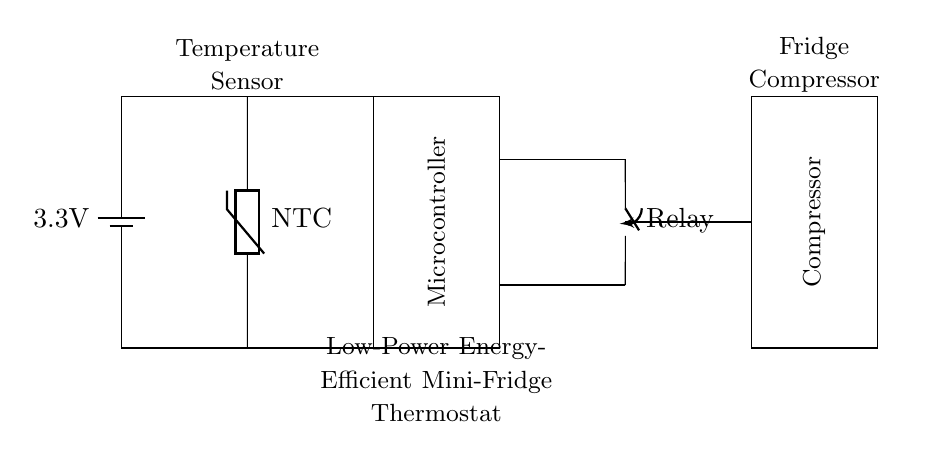What is the voltage of the power supply? The voltage of the power supply in the circuit diagram is indicated next to the battery symbol, which shows a value of 3.3V.
Answer: 3.3V What component is represented as an NTC thermistor? In the circuit, the component labeled as an NTC is a temperature sensor. NTC stands for Negative Temperature Coefficient, which means its resistance decreases as the temperature increases.
Answer: Temperature Sensor What is the role of the microcontroller in this circuit? The microcontroller is responsible for processing the signals from the temperature sensor and controlling the relay to turn the compressor on or off based on the temperature readings.
Answer: Control System How does the relay function in this thermostat circuit? The relay acts as a switch that allows the microcontroller to control the power supply to the compressor. When the temperature exceeds a certain threshold, the microcontroller activates the relay to power the compressor.
Answer: Switch Which component reduces the compressor's power consumption? The use of a low-power energy-efficient design, such as the specific microcontroller and relays, allows for reduced power consumption. The thermostat's on/off control based on temperature also contributes to this efficiency.
Answer: Energy Efficiency Design How does the temperature sensor influence the compressor operation? The temperature sensor provides real-time temperature data to the microcontroller. If the temperature rises above the set limit, the microcontroller activates the relay, allowing power to flow to the compressor, which cools the fridge.
Answer: Temperature Regulation 